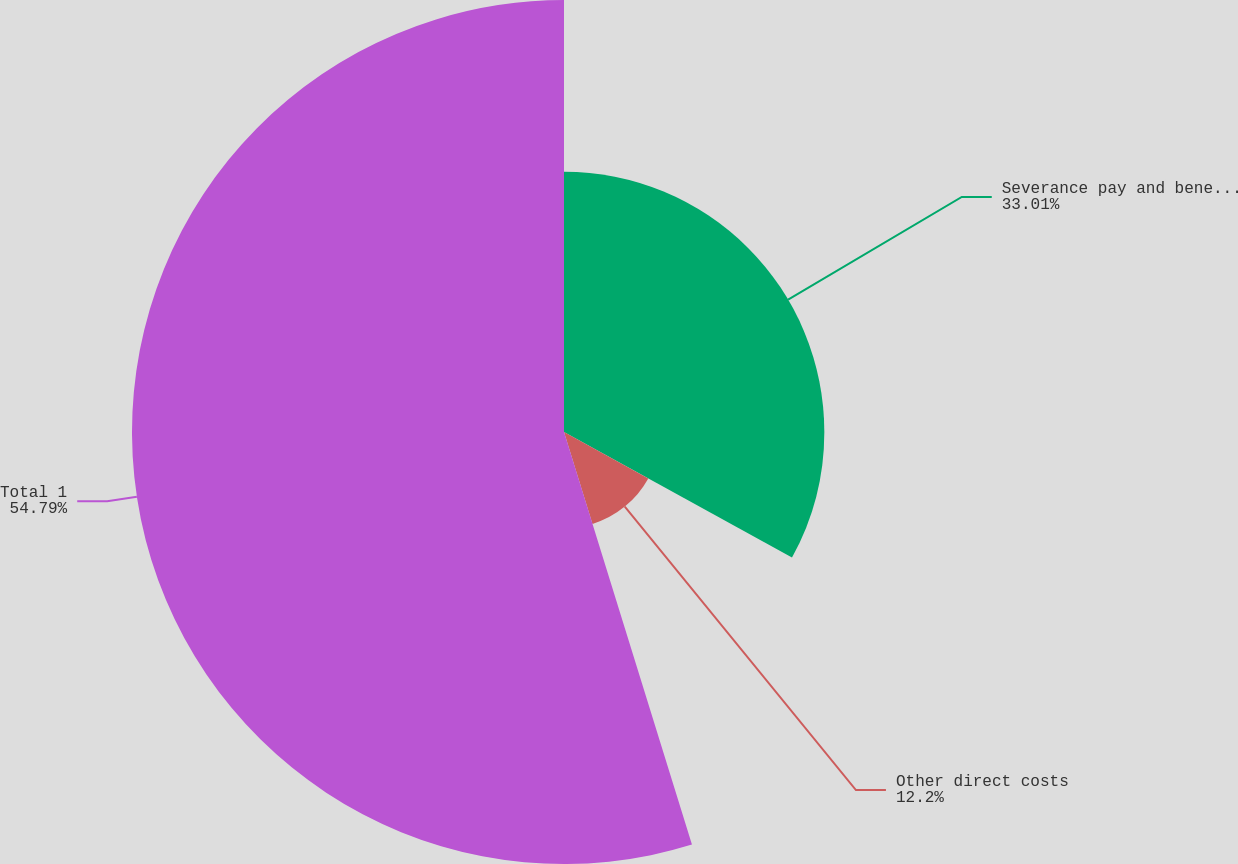<chart> <loc_0><loc_0><loc_500><loc_500><pie_chart><fcel>Severance pay and benefits<fcel>Other direct costs<fcel>Total 1<nl><fcel>33.01%<fcel>12.2%<fcel>54.78%<nl></chart> 